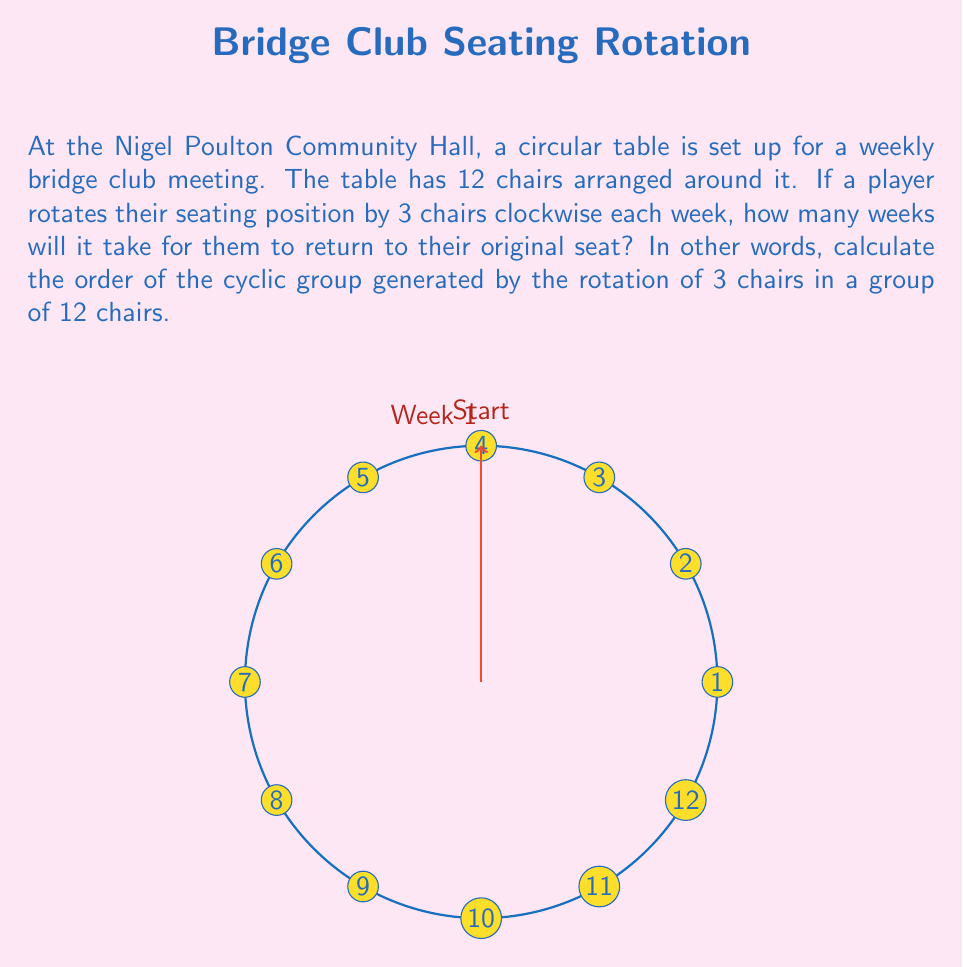Can you solve this math problem? To solve this problem, we need to find the order of the cyclic subgroup generated by the rotation of 3 chairs in a group of 12 chairs. Let's approach this step-by-step:

1) First, let's define our group operation. Here, it's the rotation by 3 chairs clockwise, which we can represent as $r_3$.

2) We need to find the smallest positive integer $n$ such that $(r_3)^n = e$, where $e$ is the identity element (no rotation).

3) Let's see what happens when we apply $r_3$ multiple times:
   $(r_3)^1 = 3$ (mod 12)
   $(r_3)^2 = 6$ (mod 12)
   $(r_3)^3 = 9$ (mod 12)
   $(r_3)^4 = 0$ (mod 12) = $e$

4) We see that after applying $r_3$ four times, we return to the starting position.

5) This means that the order of the cyclic subgroup generated by $r_3$ is 4.

6) We can verify this using the formula: $\frac{|G|}{gcd(|G|,k)}$, where $|G|$ is the order of the main group (12 in this case) and $k$ is the number of positions rotated (3 in this case).

   $\frac{12}{gcd(12,3)} = \frac{12}{3} = 4$

Therefore, it will take 4 weeks for the player to return to their original seat.
Answer: 4 weeks 